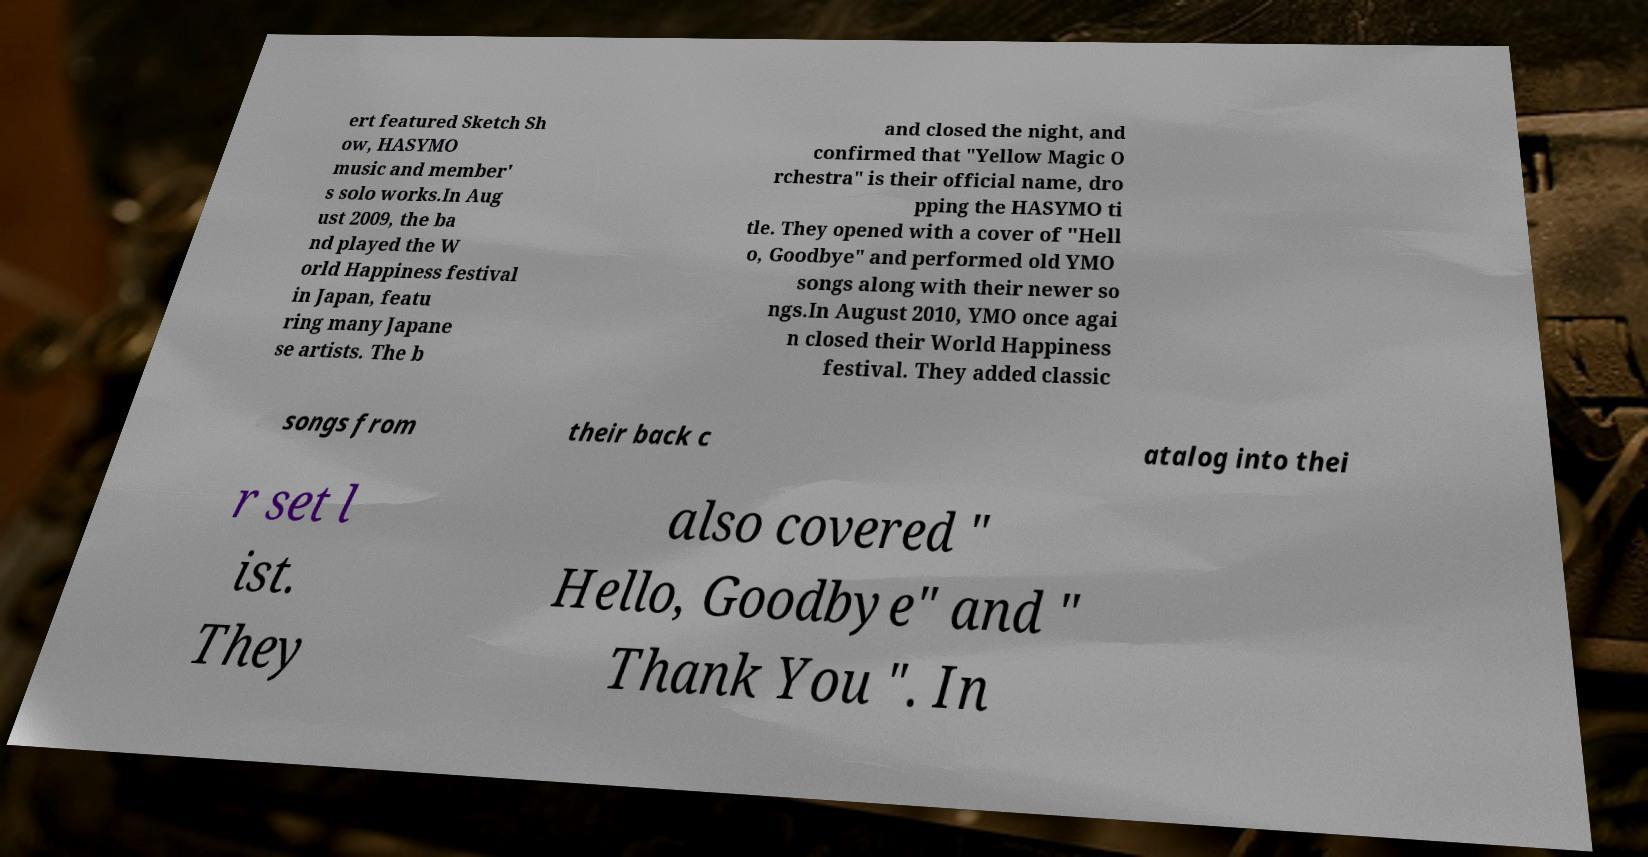Can you read and provide the text displayed in the image?This photo seems to have some interesting text. Can you extract and type it out for me? ert featured Sketch Sh ow, HASYMO music and member' s solo works.In Aug ust 2009, the ba nd played the W orld Happiness festival in Japan, featu ring many Japane se artists. The b and closed the night, and confirmed that "Yellow Magic O rchestra" is their official name, dro pping the HASYMO ti tle. They opened with a cover of "Hell o, Goodbye" and performed old YMO songs along with their newer so ngs.In August 2010, YMO once agai n closed their World Happiness festival. They added classic songs from their back c atalog into thei r set l ist. They also covered " Hello, Goodbye" and " Thank You ". In 